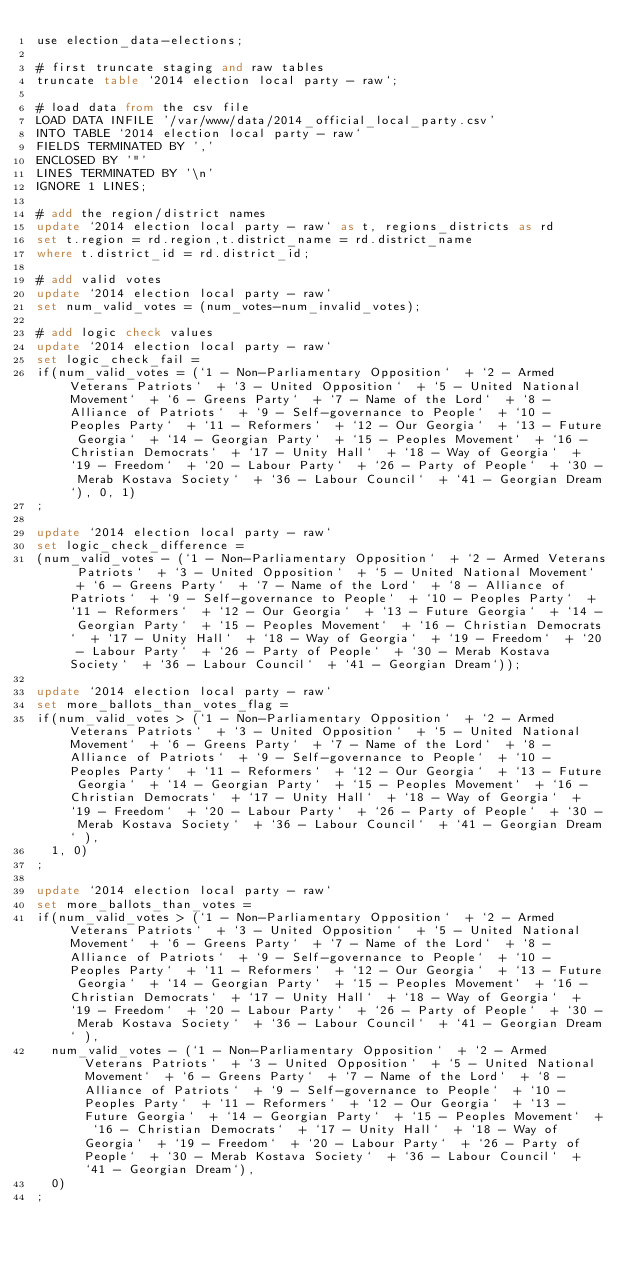Convert code to text. <code><loc_0><loc_0><loc_500><loc_500><_SQL_>use election_data-elections;

# first truncate staging and raw tables
truncate table `2014 election local party - raw`;

# load data from the csv file
LOAD DATA INFILE '/var/www/data/2014_official_local_party.csv'
INTO TABLE `2014 election local party - raw`
FIELDS TERMINATED BY ','
ENCLOSED BY '"'
LINES TERMINATED BY '\n'
IGNORE 1 LINES;

# add the region/district names
update `2014 election local party - raw` as t, regions_districts as rd
set t.region = rd.region,t.district_name = rd.district_name
where t.district_id = rd.district_id;

# add valid votes
update `2014 election local party - raw`
set num_valid_votes = (num_votes-num_invalid_votes);

# add logic check values
update `2014 election local party - raw`
set logic_check_fail = 
if(num_valid_votes = (`1 - Non-Parliamentary Opposition`  + `2 - Armed Veterans Patriots`  + `3 - United Opposition`  + `5 - United National Movement`  + `6 - Greens Party`  + `7 - Name of the Lord`  + `8 - Alliance of Patriots`  + `9 - Self-governance to People`  + `10 - Peoples Party`  + `11 - Reformers`  + `12 - Our Georgia`  + `13 - Future Georgia`  + `14 - Georgian Party`  + `15 - Peoples Movement`  + `16 - Christian Democrats`  + `17 - Unity Hall`  + `18 - Way of Georgia`  + `19 - Freedom`  + `20 - Labour Party`  + `26 - Party of People`  + `30 - Merab Kostava Society`  + `36 - Labour Council`  + `41 - Georgian Dream`), 0, 1)
;

update `2014 election local party - raw`
set logic_check_difference = 
(num_valid_votes - (`1 - Non-Parliamentary Opposition`  + `2 - Armed Veterans Patriots`  + `3 - United Opposition`  + `5 - United National Movement`  + `6 - Greens Party`  + `7 - Name of the Lord`  + `8 - Alliance of Patriots`  + `9 - Self-governance to People`  + `10 - Peoples Party`  + `11 - Reformers`  + `12 - Our Georgia`  + `13 - Future Georgia`  + `14 - Georgian Party`  + `15 - Peoples Movement`  + `16 - Christian Democrats`  + `17 - Unity Hall`  + `18 - Way of Georgia`  + `19 - Freedom`  + `20 - Labour Party`  + `26 - Party of People`  + `30 - Merab Kostava Society`  + `36 - Labour Council`  + `41 - Georgian Dream`));

update `2014 election local party - raw`
set more_ballots_than_votes_flag = 
if(num_valid_votes > (`1 - Non-Parliamentary Opposition`  + `2 - Armed Veterans Patriots`  + `3 - United Opposition`  + `5 - United National Movement`  + `6 - Greens Party`  + `7 - Name of the Lord`  + `8 - Alliance of Patriots`  + `9 - Self-governance to People`  + `10 - Peoples Party`  + `11 - Reformers`  + `12 - Our Georgia`  + `13 - Future Georgia`  + `14 - Georgian Party`  + `15 - Peoples Movement`  + `16 - Christian Democrats`  + `17 - Unity Hall`  + `18 - Way of Georgia`  + `19 - Freedom`  + `20 - Labour Party`  + `26 - Party of People`  + `30 - Merab Kostava Society`  + `36 - Labour Council`  + `41 - Georgian Dream` ), 
  1, 0)
;

update `2014 election local party - raw`
set more_ballots_than_votes = 
if(num_valid_votes > (`1 - Non-Parliamentary Opposition`  + `2 - Armed Veterans Patriots`  + `3 - United Opposition`  + `5 - United National Movement`  + `6 - Greens Party`  + `7 - Name of the Lord`  + `8 - Alliance of Patriots`  + `9 - Self-governance to People`  + `10 - Peoples Party`  + `11 - Reformers`  + `12 - Our Georgia`  + `13 - Future Georgia`  + `14 - Georgian Party`  + `15 - Peoples Movement`  + `16 - Christian Democrats`  + `17 - Unity Hall`  + `18 - Way of Georgia`  + `19 - Freedom`  + `20 - Labour Party`  + `26 - Party of People`  + `30 - Merab Kostava Society`  + `36 - Labour Council`  + `41 - Georgian Dream` ), 
  num_valid_votes - (`1 - Non-Parliamentary Opposition`  + `2 - Armed Veterans Patriots`  + `3 - United Opposition`  + `5 - United National Movement`  + `6 - Greens Party`  + `7 - Name of the Lord`  + `8 - Alliance of Patriots`  + `9 - Self-governance to People`  + `10 - Peoples Party`  + `11 - Reformers`  + `12 - Our Georgia`  + `13 - Future Georgia`  + `14 - Georgian Party`  + `15 - Peoples Movement`  + `16 - Christian Democrats`  + `17 - Unity Hall`  + `18 - Way of Georgia`  + `19 - Freedom`  + `20 - Labour Party`  + `26 - Party of People`  + `30 - Merab Kostava Society`  + `36 - Labour Council`  + `41 - Georgian Dream`), 
  0)
;
</code> 